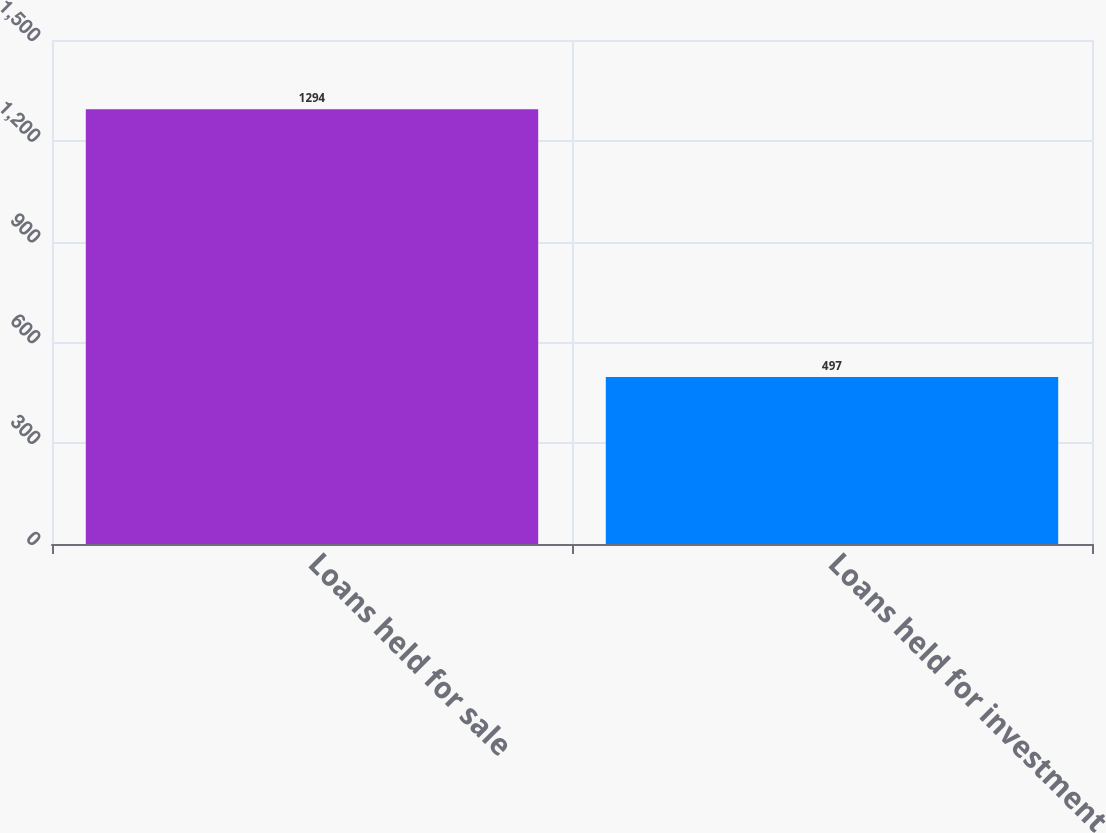Convert chart to OTSL. <chart><loc_0><loc_0><loc_500><loc_500><bar_chart><fcel>Loans held for sale<fcel>Loans held for investment<nl><fcel>1294<fcel>497<nl></chart> 